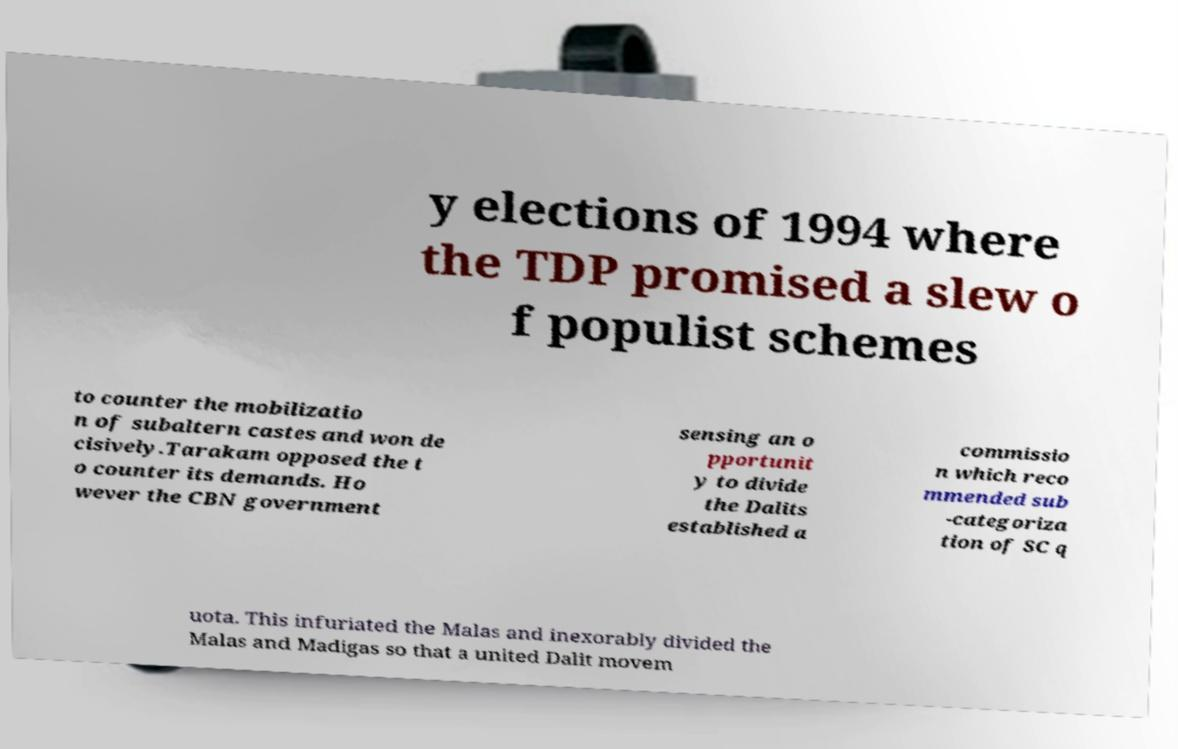Could you assist in decoding the text presented in this image and type it out clearly? y elections of 1994 where the TDP promised a slew o f populist schemes to counter the mobilizatio n of subaltern castes and won de cisively.Tarakam opposed the t o counter its demands. Ho wever the CBN government sensing an o pportunit y to divide the Dalits established a commissio n which reco mmended sub -categoriza tion of SC q uota. This infuriated the Malas and inexorably divided the Malas and Madigas so that a united Dalit movem 